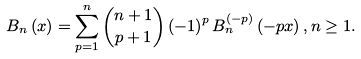Convert formula to latex. <formula><loc_0><loc_0><loc_500><loc_500>B _ { n } \left ( x \right ) = \sum _ { p = 1 } ^ { n } \binom { n + 1 } { p + 1 } \left ( - 1 \right ) ^ { p } B _ { n } ^ { \left ( - p \right ) } \left ( - p x \right ) , n \geq 1 .</formula> 